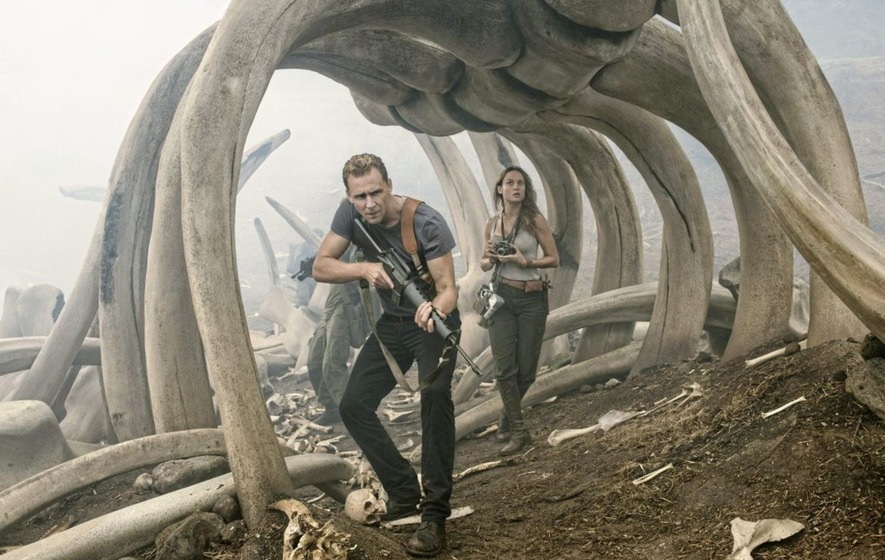Do you think the characters are in immediate danger? Given the tense body language of the characters and the eerie atmosphere, it's quite likely that they are indeed in immediate danger. The setting, with its foggy environment and giant bones, suggests that they might be traversing a territory inhabited by large, potentially hostile creatures. 